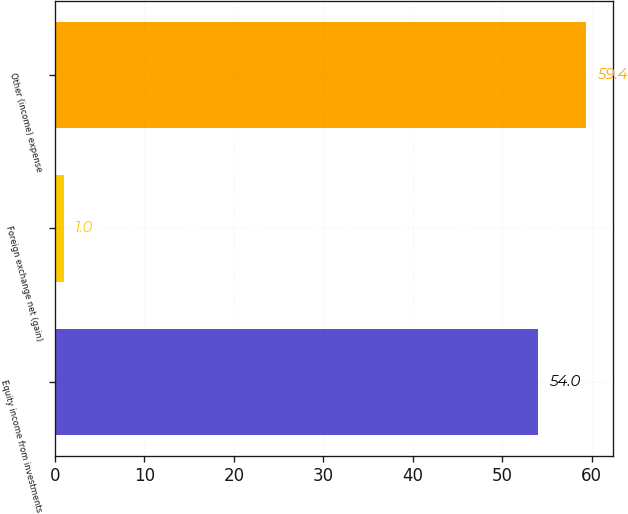Convert chart. <chart><loc_0><loc_0><loc_500><loc_500><bar_chart><fcel>Equity income from investments<fcel>Foreign exchange net (gain)<fcel>Other (income) expense<nl><fcel>54<fcel>1<fcel>59.4<nl></chart> 